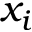<formula> <loc_0><loc_0><loc_500><loc_500>x _ { i }</formula> 